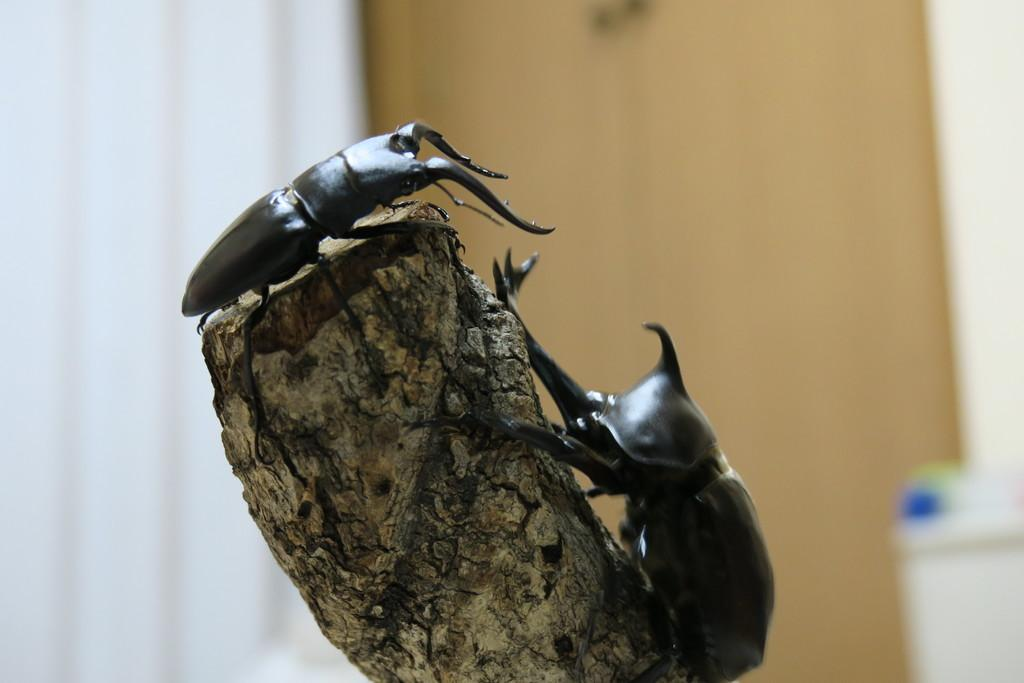What is the main subject of the image? The main subject of the image is insects on a dry stick. Can you describe the background of the image? The background of the image is blurry. What type of mailbox is visible on the side of the image? There is no mailbox present in the image. What effect does the insects have on the dry stick in the image? The insects themselves do not have an effect on the dry stick in the image; they are simply resting on it. 